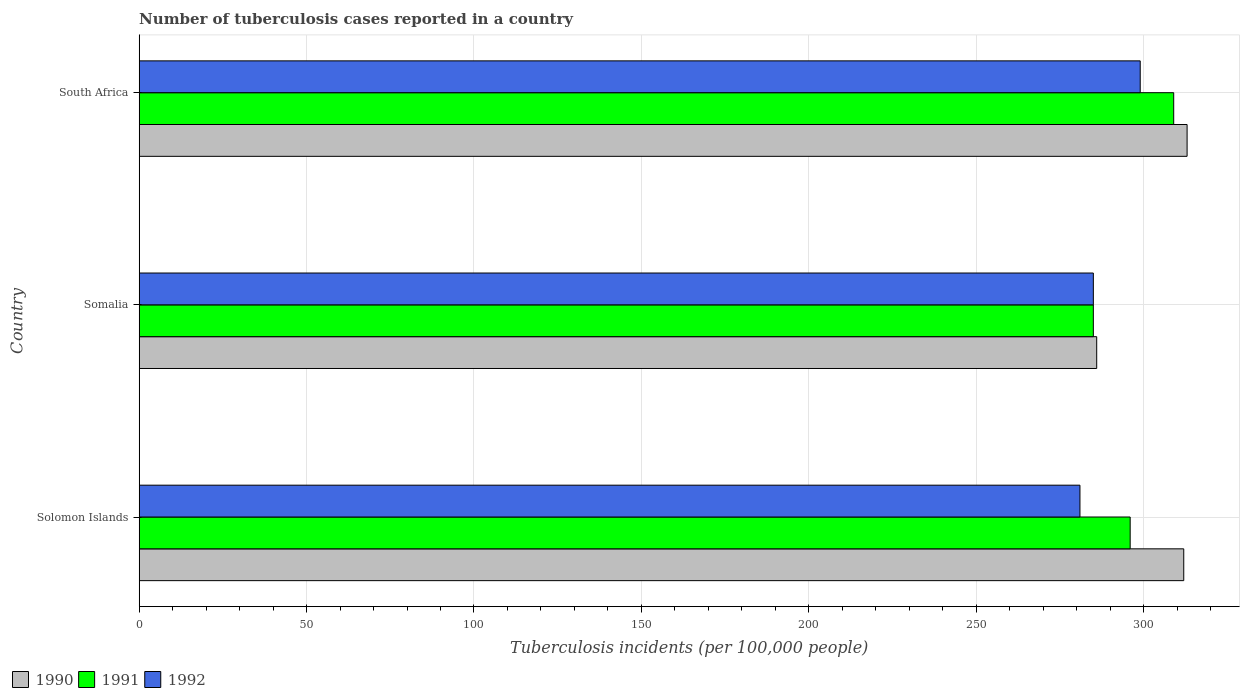How many groups of bars are there?
Give a very brief answer. 3. Are the number of bars per tick equal to the number of legend labels?
Your response must be concise. Yes. How many bars are there on the 3rd tick from the top?
Make the answer very short. 3. How many bars are there on the 2nd tick from the bottom?
Your answer should be very brief. 3. What is the label of the 1st group of bars from the top?
Give a very brief answer. South Africa. In how many cases, is the number of bars for a given country not equal to the number of legend labels?
Keep it short and to the point. 0. What is the number of tuberculosis cases reported in in 1991 in South Africa?
Your answer should be very brief. 309. Across all countries, what is the maximum number of tuberculosis cases reported in in 1992?
Keep it short and to the point. 299. Across all countries, what is the minimum number of tuberculosis cases reported in in 1992?
Provide a succinct answer. 281. In which country was the number of tuberculosis cases reported in in 1992 maximum?
Your answer should be very brief. South Africa. In which country was the number of tuberculosis cases reported in in 1990 minimum?
Offer a terse response. Somalia. What is the total number of tuberculosis cases reported in in 1991 in the graph?
Offer a terse response. 890. What is the difference between the number of tuberculosis cases reported in in 1992 in Solomon Islands and that in Somalia?
Your response must be concise. -4. What is the difference between the number of tuberculosis cases reported in in 1991 in Solomon Islands and the number of tuberculosis cases reported in in 1992 in Somalia?
Your response must be concise. 11. What is the average number of tuberculosis cases reported in in 1990 per country?
Your answer should be very brief. 303.67. In how many countries, is the number of tuberculosis cases reported in in 1991 greater than 200 ?
Keep it short and to the point. 3. What is the ratio of the number of tuberculosis cases reported in in 1990 in Solomon Islands to that in Somalia?
Provide a short and direct response. 1.09. Is the number of tuberculosis cases reported in in 1992 in Somalia less than that in South Africa?
Ensure brevity in your answer.  Yes. What is the difference between the highest and the second highest number of tuberculosis cases reported in in 1992?
Keep it short and to the point. 14. Is the sum of the number of tuberculosis cases reported in in 1991 in Solomon Islands and Somalia greater than the maximum number of tuberculosis cases reported in in 1992 across all countries?
Your answer should be very brief. Yes. What does the 2nd bar from the top in Solomon Islands represents?
Provide a succinct answer. 1991. How many countries are there in the graph?
Provide a short and direct response. 3. What is the title of the graph?
Provide a short and direct response. Number of tuberculosis cases reported in a country. Does "1973" appear as one of the legend labels in the graph?
Keep it short and to the point. No. What is the label or title of the X-axis?
Give a very brief answer. Tuberculosis incidents (per 100,0 people). What is the Tuberculosis incidents (per 100,000 people) of 1990 in Solomon Islands?
Your answer should be very brief. 312. What is the Tuberculosis incidents (per 100,000 people) of 1991 in Solomon Islands?
Your response must be concise. 296. What is the Tuberculosis incidents (per 100,000 people) in 1992 in Solomon Islands?
Make the answer very short. 281. What is the Tuberculosis incidents (per 100,000 people) in 1990 in Somalia?
Offer a terse response. 286. What is the Tuberculosis incidents (per 100,000 people) of 1991 in Somalia?
Offer a terse response. 285. What is the Tuberculosis incidents (per 100,000 people) in 1992 in Somalia?
Provide a short and direct response. 285. What is the Tuberculosis incidents (per 100,000 people) in 1990 in South Africa?
Make the answer very short. 313. What is the Tuberculosis incidents (per 100,000 people) in 1991 in South Africa?
Offer a very short reply. 309. What is the Tuberculosis incidents (per 100,000 people) of 1992 in South Africa?
Offer a terse response. 299. Across all countries, what is the maximum Tuberculosis incidents (per 100,000 people) in 1990?
Your answer should be compact. 313. Across all countries, what is the maximum Tuberculosis incidents (per 100,000 people) of 1991?
Keep it short and to the point. 309. Across all countries, what is the maximum Tuberculosis incidents (per 100,000 people) of 1992?
Your response must be concise. 299. Across all countries, what is the minimum Tuberculosis incidents (per 100,000 people) in 1990?
Provide a succinct answer. 286. Across all countries, what is the minimum Tuberculosis incidents (per 100,000 people) of 1991?
Give a very brief answer. 285. Across all countries, what is the minimum Tuberculosis incidents (per 100,000 people) of 1992?
Your answer should be compact. 281. What is the total Tuberculosis incidents (per 100,000 people) in 1990 in the graph?
Keep it short and to the point. 911. What is the total Tuberculosis incidents (per 100,000 people) of 1991 in the graph?
Provide a short and direct response. 890. What is the total Tuberculosis incidents (per 100,000 people) of 1992 in the graph?
Provide a succinct answer. 865. What is the difference between the Tuberculosis incidents (per 100,000 people) in 1990 in Solomon Islands and that in Somalia?
Give a very brief answer. 26. What is the difference between the Tuberculosis incidents (per 100,000 people) of 1991 in Solomon Islands and that in Somalia?
Ensure brevity in your answer.  11. What is the difference between the Tuberculosis incidents (per 100,000 people) of 1992 in Solomon Islands and that in Somalia?
Keep it short and to the point. -4. What is the difference between the Tuberculosis incidents (per 100,000 people) in 1991 in Solomon Islands and that in South Africa?
Ensure brevity in your answer.  -13. What is the difference between the Tuberculosis incidents (per 100,000 people) of 1992 in Solomon Islands and that in South Africa?
Offer a terse response. -18. What is the difference between the Tuberculosis incidents (per 100,000 people) in 1990 in Solomon Islands and the Tuberculosis incidents (per 100,000 people) in 1991 in South Africa?
Offer a very short reply. 3. What is the average Tuberculosis incidents (per 100,000 people) of 1990 per country?
Give a very brief answer. 303.67. What is the average Tuberculosis incidents (per 100,000 people) in 1991 per country?
Keep it short and to the point. 296.67. What is the average Tuberculosis incidents (per 100,000 people) in 1992 per country?
Your answer should be very brief. 288.33. What is the difference between the Tuberculosis incidents (per 100,000 people) of 1991 and Tuberculosis incidents (per 100,000 people) of 1992 in Solomon Islands?
Provide a short and direct response. 15. What is the difference between the Tuberculosis incidents (per 100,000 people) of 1990 and Tuberculosis incidents (per 100,000 people) of 1991 in Somalia?
Offer a very short reply. 1. What is the difference between the Tuberculosis incidents (per 100,000 people) in 1991 and Tuberculosis incidents (per 100,000 people) in 1992 in Somalia?
Provide a succinct answer. 0. What is the difference between the Tuberculosis incidents (per 100,000 people) of 1990 and Tuberculosis incidents (per 100,000 people) of 1991 in South Africa?
Offer a terse response. 4. What is the ratio of the Tuberculosis incidents (per 100,000 people) of 1991 in Solomon Islands to that in Somalia?
Ensure brevity in your answer.  1.04. What is the ratio of the Tuberculosis incidents (per 100,000 people) of 1992 in Solomon Islands to that in Somalia?
Your response must be concise. 0.99. What is the ratio of the Tuberculosis incidents (per 100,000 people) of 1990 in Solomon Islands to that in South Africa?
Your response must be concise. 1. What is the ratio of the Tuberculosis incidents (per 100,000 people) in 1991 in Solomon Islands to that in South Africa?
Make the answer very short. 0.96. What is the ratio of the Tuberculosis incidents (per 100,000 people) of 1992 in Solomon Islands to that in South Africa?
Keep it short and to the point. 0.94. What is the ratio of the Tuberculosis incidents (per 100,000 people) of 1990 in Somalia to that in South Africa?
Your answer should be compact. 0.91. What is the ratio of the Tuberculosis incidents (per 100,000 people) in 1991 in Somalia to that in South Africa?
Ensure brevity in your answer.  0.92. What is the ratio of the Tuberculosis incidents (per 100,000 people) in 1992 in Somalia to that in South Africa?
Your answer should be compact. 0.95. What is the difference between the highest and the second highest Tuberculosis incidents (per 100,000 people) in 1990?
Ensure brevity in your answer.  1. What is the difference between the highest and the second highest Tuberculosis incidents (per 100,000 people) of 1991?
Keep it short and to the point. 13. What is the difference between the highest and the lowest Tuberculosis incidents (per 100,000 people) of 1991?
Your answer should be compact. 24. 